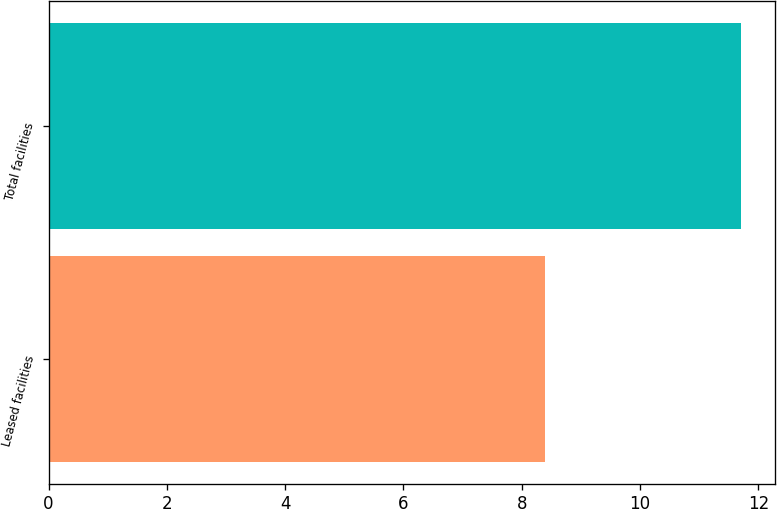Convert chart to OTSL. <chart><loc_0><loc_0><loc_500><loc_500><bar_chart><fcel>Leased facilities<fcel>Total facilities<nl><fcel>8.4<fcel>11.7<nl></chart> 